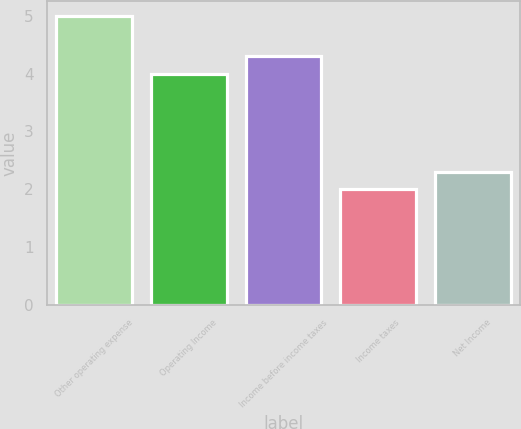Convert chart to OTSL. <chart><loc_0><loc_0><loc_500><loc_500><bar_chart><fcel>Other operating expense<fcel>Operating Income<fcel>Income before income taxes<fcel>Income taxes<fcel>Net Income<nl><fcel>5<fcel>4<fcel>4.3<fcel>2<fcel>2.3<nl></chart> 